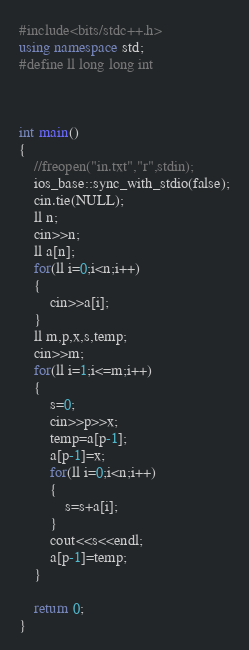Convert code to text. <code><loc_0><loc_0><loc_500><loc_500><_C++_>#include<bits/stdc++.h>
using namespace std;
#define ll long long int



int main()
{
    //freopen("in.txt","r",stdin);
    ios_base::sync_with_stdio(false);
    cin.tie(NULL);
    ll n;
    cin>>n;
    ll a[n];
    for(ll i=0;i<n;i++)
    {
    	cin>>a[i];
    }
    ll m,p,x,s,temp;
    cin>>m;
    for(ll i=1;i<=m;i++)
    {   
    	s=0;
    	cin>>p>>x;
    	temp=a[p-1];
    	a[p-1]=x;
    	for(ll i=0;i<n;i++)
    	{
    		s=s+a[i];
    	}
    	cout<<s<<endl;
    	a[p-1]=temp;
    }
   
    return 0;
}</code> 